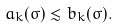<formula> <loc_0><loc_0><loc_500><loc_500>a _ { k } ( \sigma ) \lesssim b _ { k } ( \sigma ) .</formula> 